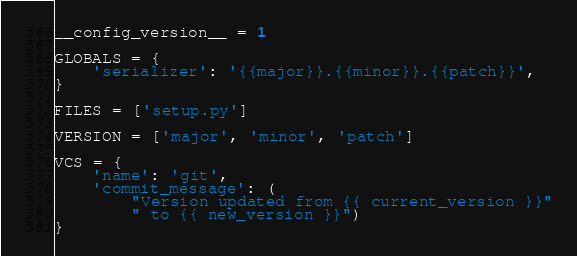<code> <loc_0><loc_0><loc_500><loc_500><_Python_>__config_version__ = 1

GLOBALS = {
    'serializer': '{{major}}.{{minor}}.{{patch}}',
}

FILES = ['setup.py']

VERSION = ['major', 'minor', 'patch']

VCS = {
    'name': 'git',
    'commit_message': (
        "Version updated from {{ current_version }}"
        " to {{ new_version }}")
}
</code> 